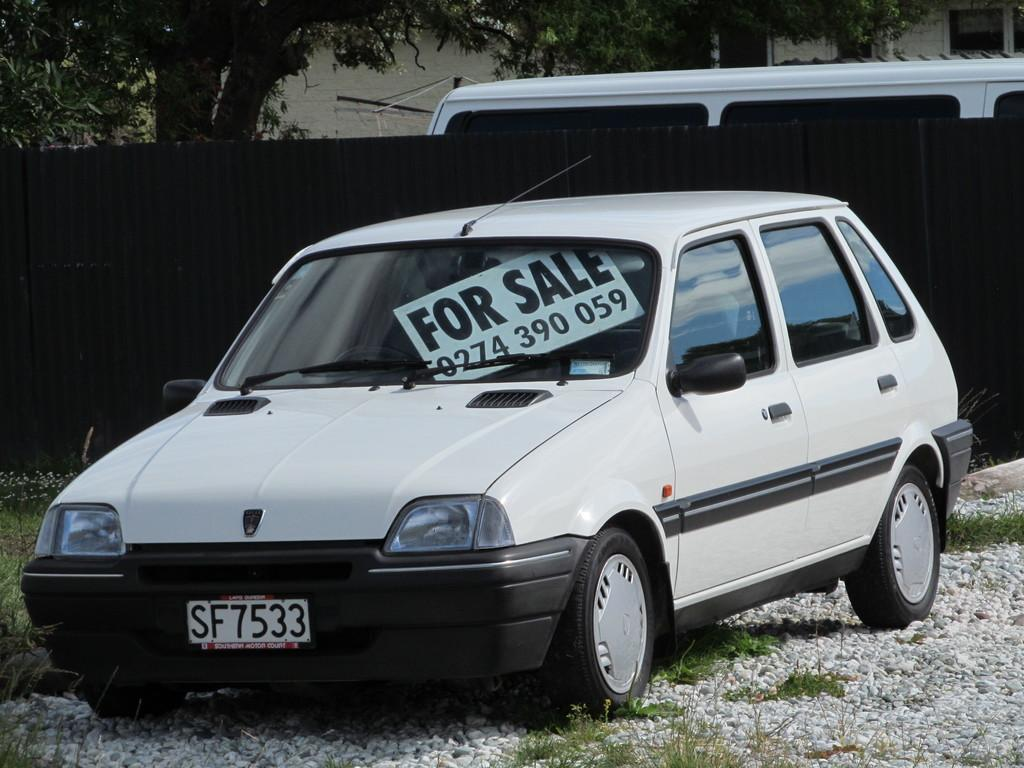<image>
Offer a succinct explanation of the picture presented. A white car that has a sign in the windshield that says For Sale 